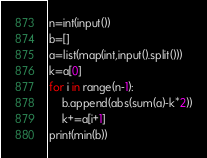<code> <loc_0><loc_0><loc_500><loc_500><_Python_>n=int(input())
b=[]
a=list(map(int,input().split()))
k=a[0]
for i in range(n-1):
	b.append(abs(sum(a)-k*2))
	k+=a[i+1]
print(min(b))
</code> 